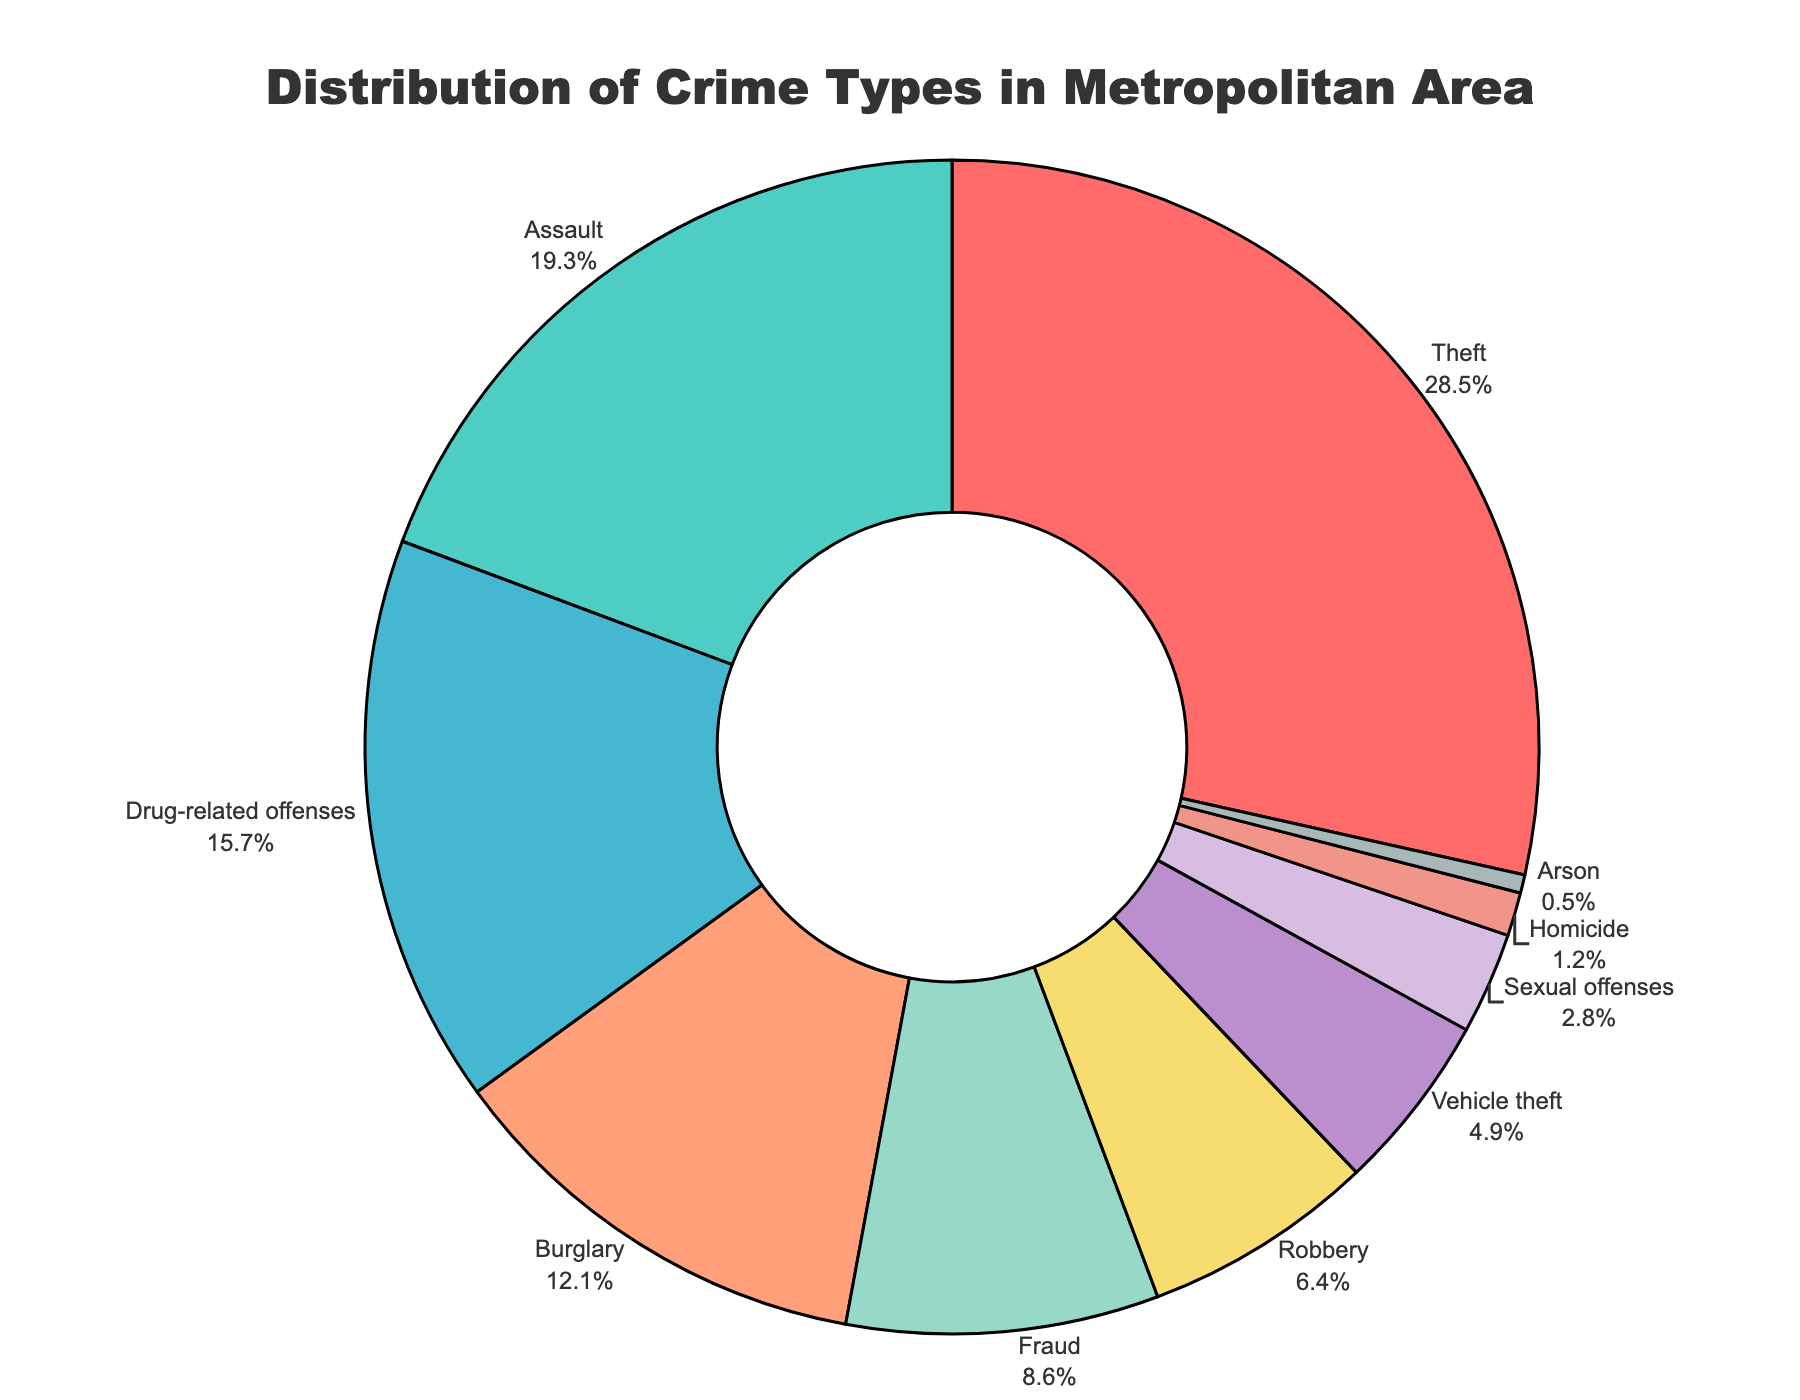What's the most prevalent type of crime in this metropolitan area? By examining the pie chart, it's evident that the section representing 'Theft' occupies the largest area, hence it has the highest percentage of 28.5%.
Answer: Theft Which crime has a greater percentage: Drug-related offenses or Burglary? To compare the two, observe the corresponding segments in the pie chart. 'Drug-related offenses' has a larger share at 15.7%, while 'Burglary' has 12.1%. Thus, Drug-related offenses has a higher percentage.
Answer: Drug-related offenses How much of a difference is there in percentage between Assault and Fraud? Examine the segments for 'Assault' and 'Fraud'. 'Assault' has 19.3% and 'Fraud' has 8.6%. The difference is calculated as 19.3% - 8.6% = 10.7%.
Answer: 10.7% What's the combined percentage of Vehicle theft and Sexual offenses? Look at the pie chart for the percentages of 'Vehicle theft' (4.9%) and 'Sexual offenses' (2.8%). Adding these gives 4.9% + 2.8% = 7.7%.
Answer: 7.7% Which crime type is represented by a yellow segment? The yellow segment should correspond to the 'Fraud' category, based on its visual placement in the pie chart.
Answer: Fraud What percentage of crimes are categorized as either Homicide or Arson? Checking the chart, 'Homicide' is 1.2% and 'Arson' is 0.5%. Summing these gives 1.2% + 0.5% = 1.7%.
Answer: 1.7% Is the segment for Robbery larger than the segment for Vehicle theft? Look at the sizes of the segments. 'Robbery' is 6.4% and 'Vehicle theft' is 4.9%. Since 6.4% is greater than 4.9%, the Robbery segment is larger.
Answer: Yes Which crime type has the smallest percentage, and what is this percentage? The pie chart indicates 'Arson' has the smallest segment with 0.5%.
Answer: Arson, 0.5% 